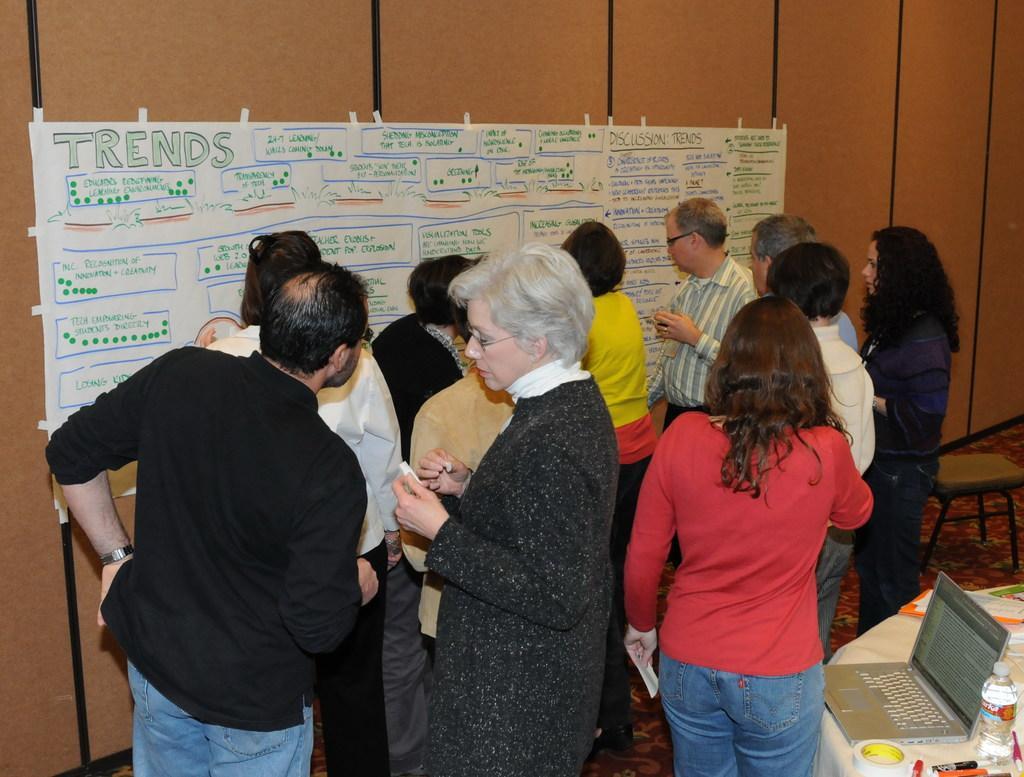Describe this image in one or two sentences. In this image we can see people standing. And we can see the laptop, bottles and some objects on the table. And we can see a chair. And we can see the wooden wall. And we can see the white poster with some text on it. 